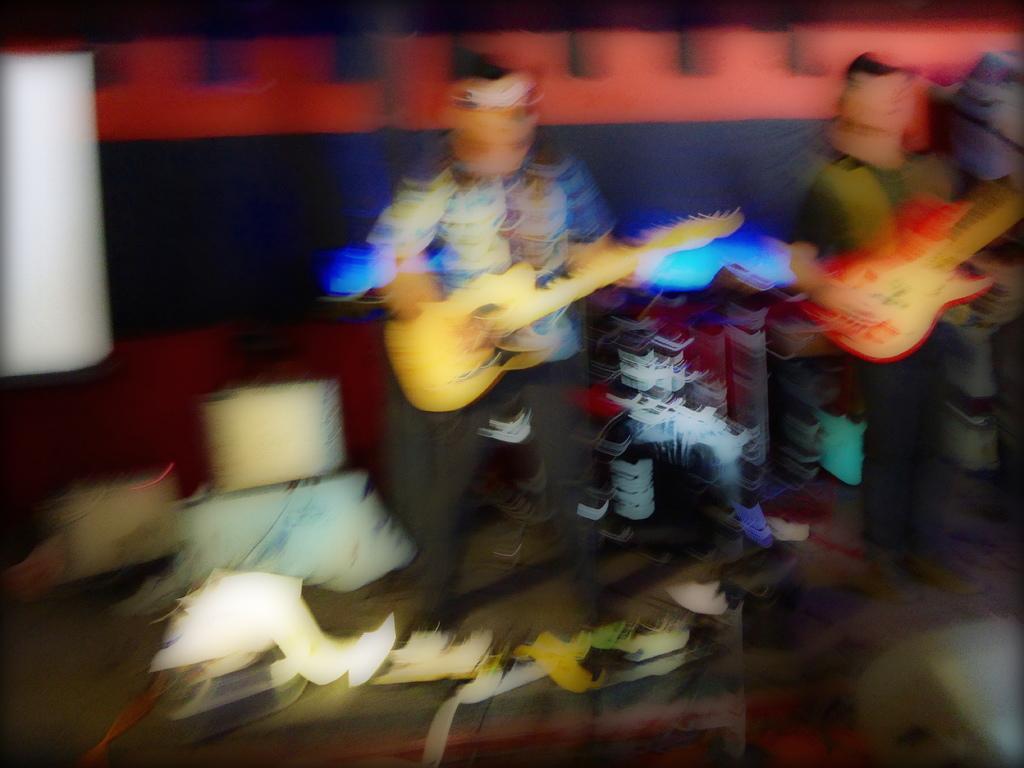In one or two sentences, can you explain what this image depicts? This is a blur image and here we can see cartoons holding guitars and there are some other objects. 